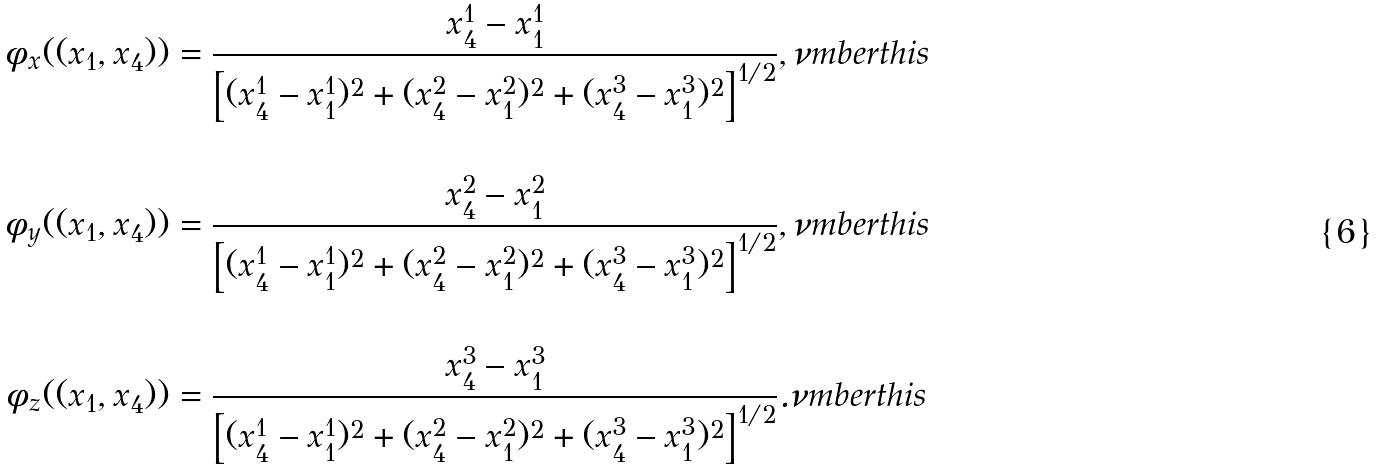<formula> <loc_0><loc_0><loc_500><loc_500>\phi _ { x } ( ( x _ { 1 } , x _ { 4 } ) ) & = \frac { x _ { 4 } ^ { 1 } - x _ { 1 } ^ { 1 } } { \left [ ( x _ { 4 } ^ { 1 } - x _ { 1 } ^ { 1 } ) ^ { 2 } + ( x _ { 4 } ^ { 2 } - x _ { 1 } ^ { 2 } ) ^ { 2 } + ( x _ { 4 } ^ { 3 } - x _ { 1 } ^ { 3 } ) ^ { 2 } \right ] ^ { 1 / 2 } } , \nu m b e r t h i s \\ \\ \phi _ { y } ( ( x _ { 1 } , x _ { 4 } ) ) & = \frac { x _ { 4 } ^ { 2 } - x _ { 1 } ^ { 2 } } { \left [ ( x _ { 4 } ^ { 1 } - x _ { 1 } ^ { 1 } ) ^ { 2 } + ( x _ { 4 } ^ { 2 } - x _ { 1 } ^ { 2 } ) ^ { 2 } + ( x _ { 4 } ^ { 3 } - x _ { 1 } ^ { 3 } ) ^ { 2 } \right ] ^ { 1 / 2 } } , \nu m b e r t h i s \\ \\ \phi _ { z } ( ( x _ { 1 } , x _ { 4 } ) ) & = \frac { x _ { 4 } ^ { 3 } - x _ { 1 } ^ { 3 } } { \left [ ( x _ { 4 } ^ { 1 } - x _ { 1 } ^ { 1 } ) ^ { 2 } + ( x _ { 4 } ^ { 2 } - x _ { 1 } ^ { 2 } ) ^ { 2 } + ( x _ { 4 } ^ { 3 } - x _ { 1 } ^ { 3 } ) ^ { 2 } \right ] ^ { 1 / 2 } } . \nu m b e r t h i s</formula> 